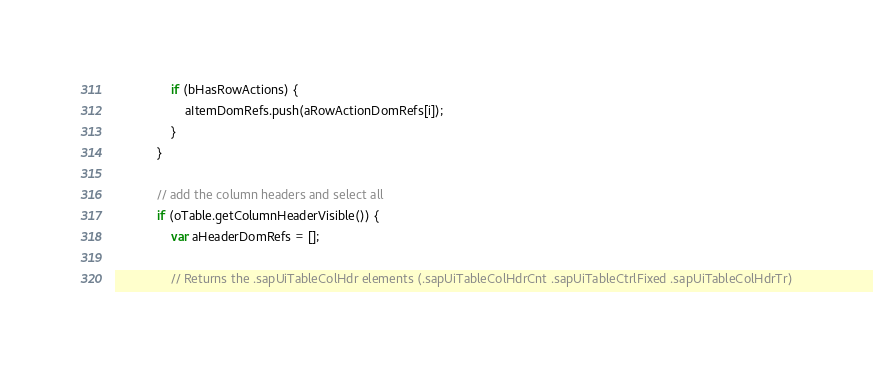Convert code to text. <code><loc_0><loc_0><loc_500><loc_500><_JavaScript_>				if (bHasRowActions) {
					aItemDomRefs.push(aRowActionDomRefs[i]);
				}
			}

			// add the column headers and select all
			if (oTable.getColumnHeaderVisible()) {
				var aHeaderDomRefs = [];

				// Returns the .sapUiTableColHdr elements (.sapUiTableColHdrCnt .sapUiTableCtrlFixed .sapUiTableColHdrTr)</code> 